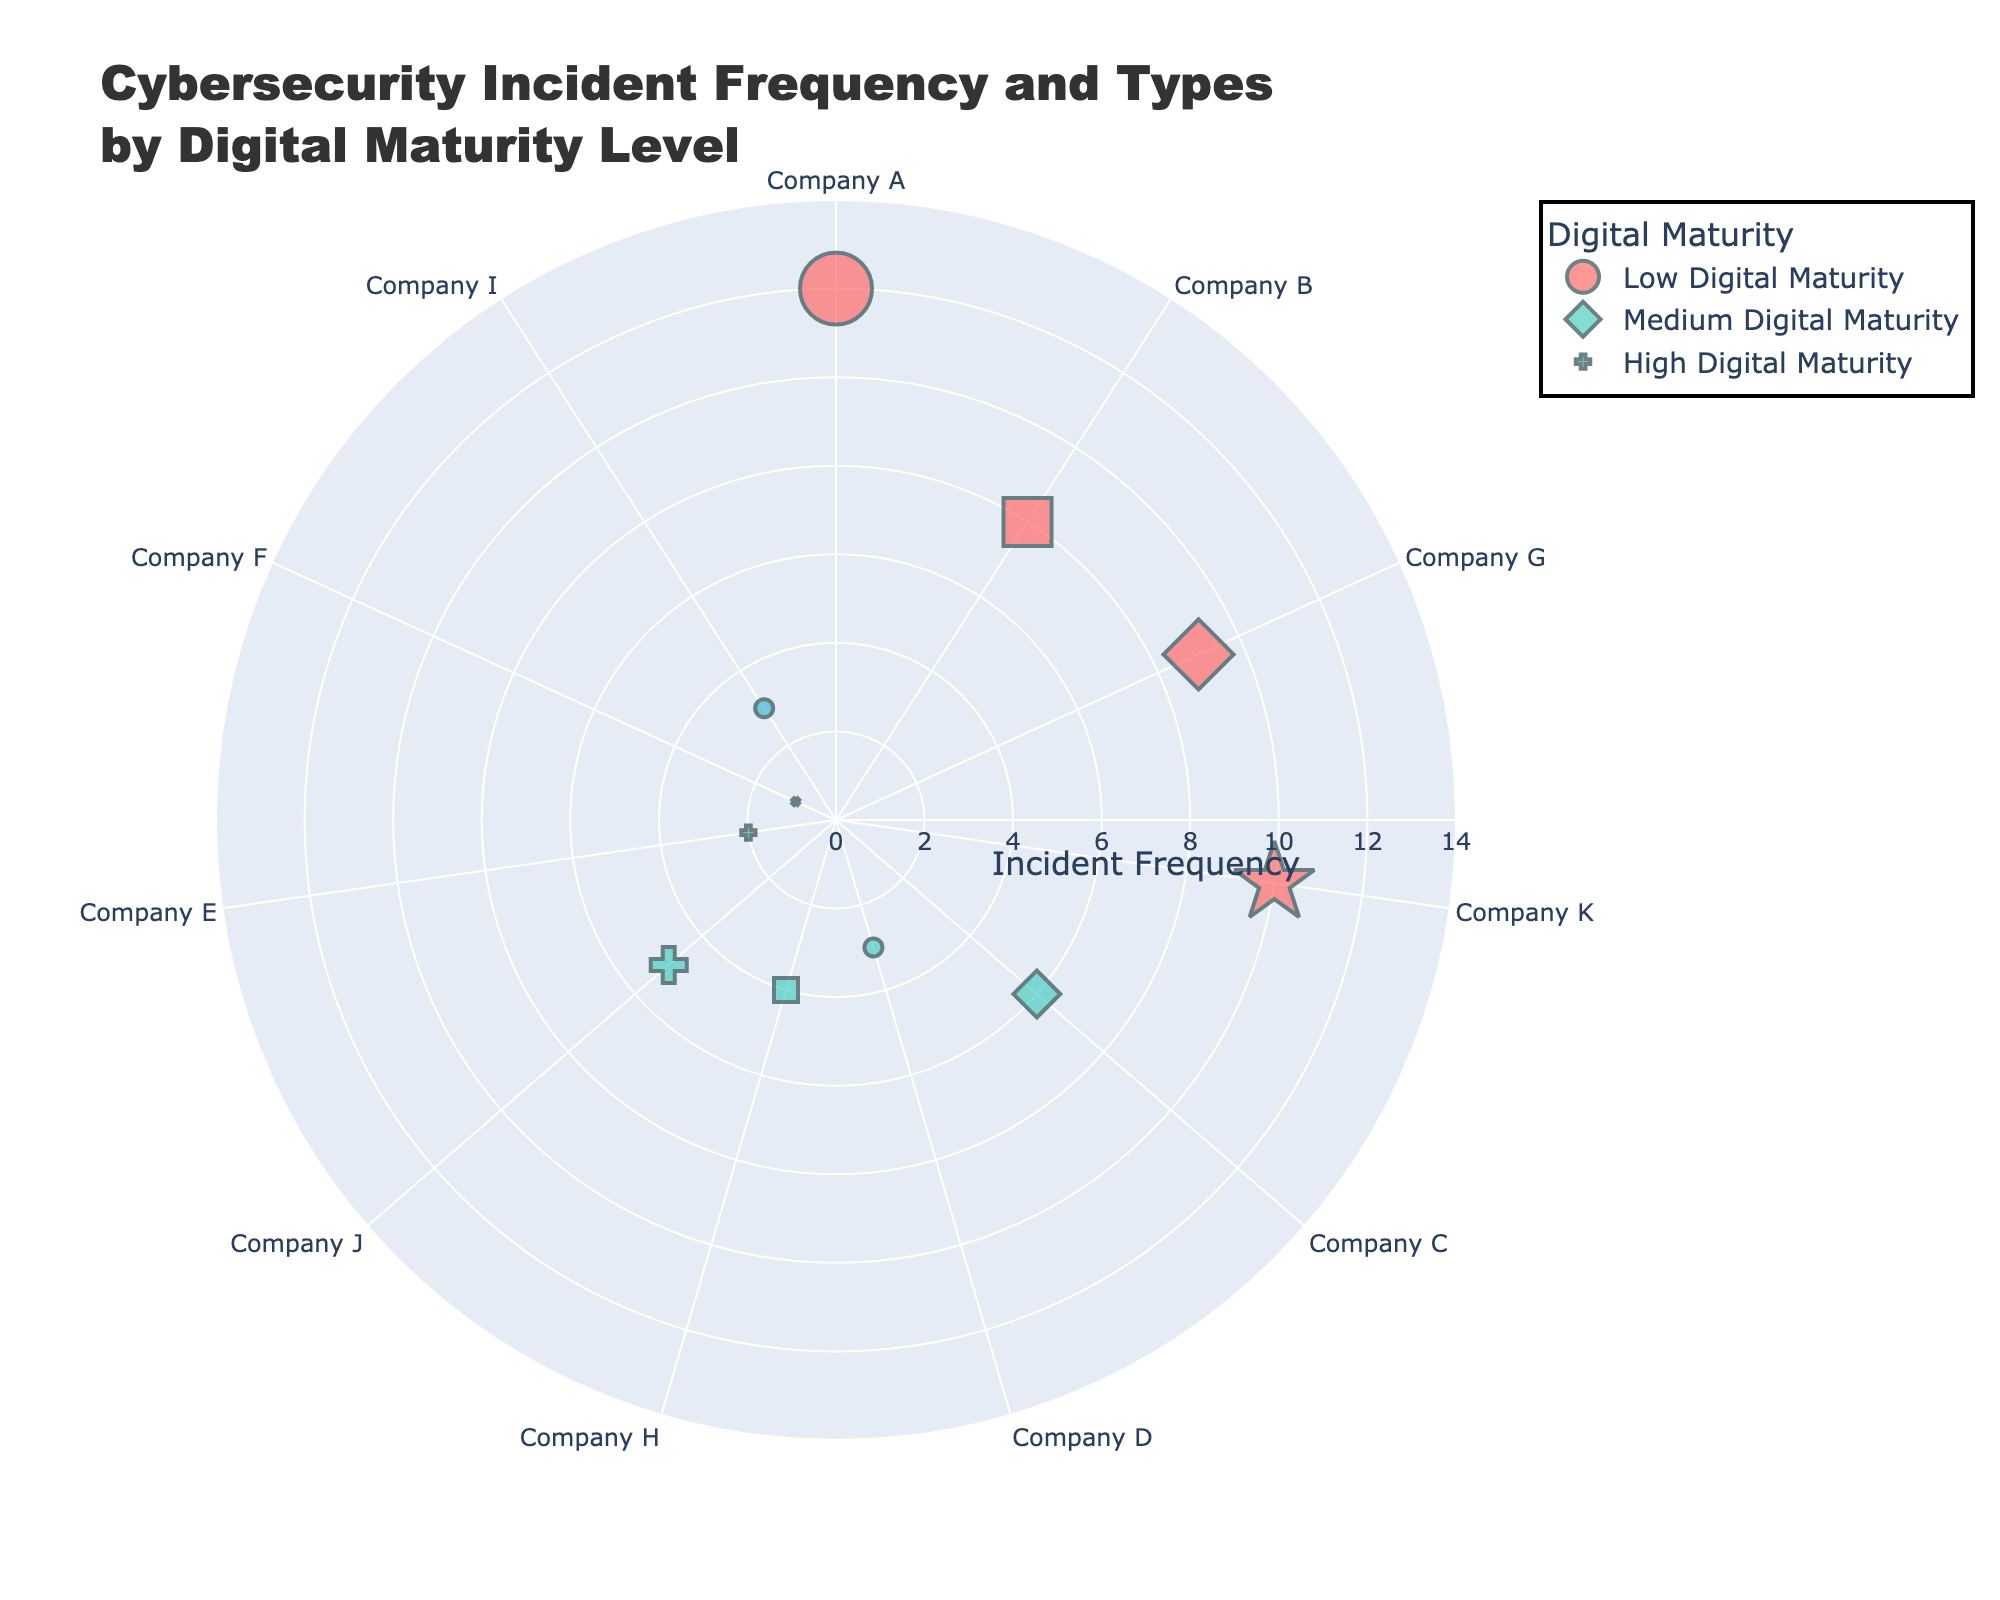Which category has the highest frequency of incidents in a single company? To find the highest frequency of incidents in a single company, we look for the highest value in the "Incident Frequency" axis across all categories. The highest value is 12 incidents, occurring in the 'Low Digital Maturity' category for Company A.
Answer: Low Digital Maturity What is the total number of phishing incidents across all companies? To calculate the total number of phishing incidents, sum the incident frequencies for the companies that reported phishing incidents: Company A (12), Company D (3), and Company I (3), which adds up to (12 + 3 + 3) = 18.
Answer: 18 How does the average incident frequency in the 'High Digital Maturity' category compare to the 'Low Digital Maturity' category? Calculate the average incident frequency for both categories and then compare them. 'High Digital Maturity' has incidents (2, 1, 3), so the average is (2 + 1 + 3) / 3 = 2. 'Low Digital Maturity' has incidents (12, 8, 9, 10), so the average is (12 + 8 + 9 + 10) / 4 = 9.75. Hence, the average incident frequency in 'High Digital Maturity' is much lower than in 'Low Digital Maturity'.
Answer: Lower Which incident type is represented by the largest marker size in the figure? To determine the incident type represented by the largest marker size, identify the company with the highest incident frequency, which is Company A with 12 incidents, and the incident type is Phishing. The marker size corresponds to the incident frequency.
Answer: Phishing Do companies with higher digital maturity levels experience fewer incidents on average compared to those with lower digital maturity levels? Calculate and compare the average incident frequencies of the 'Low', 'Medium', and 'High Digital Maturity' categories. 'Low Digital Maturity' average is 9.75, 'Medium Digital Maturity' average is (6 + 3 + 4 + 5) / 4 = 4.5, and 'High Digital Maturity' average is 2. Therefore, companies with higher digital maturity levels experience fewer incidents on average.
Answer: Yes Which data breach incident has the highest frequency, and which category does it belong to? To find the highest frequency of data breach incidents, locate the data breach incident among the records. Company K has a data breach incident with a frequency of 10 and belongs to the 'Low Digital Maturity' category.
Answer: Company K, Low Digital Maturity What is the total number of different incident types reported by medium digital maturity companies? The 'Medium Digital Maturity' category includes incidents of types: Ransomware, Phishing, Malware, and DDoS Attack. Counting these, there are 4 different incident types reported.
Answer: 4 Which company has the lowest incident frequency in the 'High Digital Maturity' category? Look for the company in the 'High Digital Maturity' category with the lowest incident frequency, which is Company F with 1 incident.
Answer: Company F 